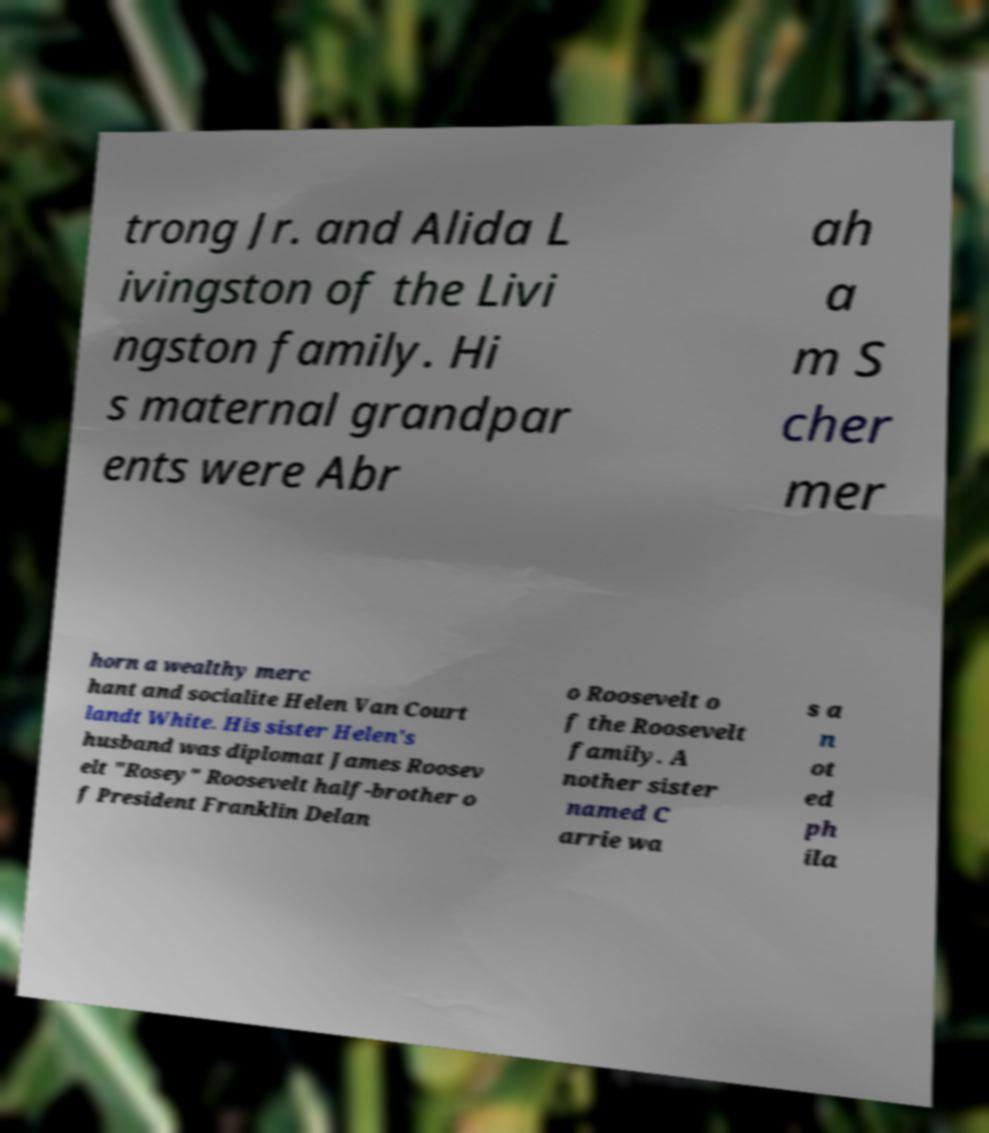I need the written content from this picture converted into text. Can you do that? trong Jr. and Alida L ivingston of the Livi ngston family. Hi s maternal grandpar ents were Abr ah a m S cher mer horn a wealthy merc hant and socialite Helen Van Court landt White. His sister Helen's husband was diplomat James Roosev elt "Rosey" Roosevelt half-brother o f President Franklin Delan o Roosevelt o f the Roosevelt family. A nother sister named C arrie wa s a n ot ed ph ila 